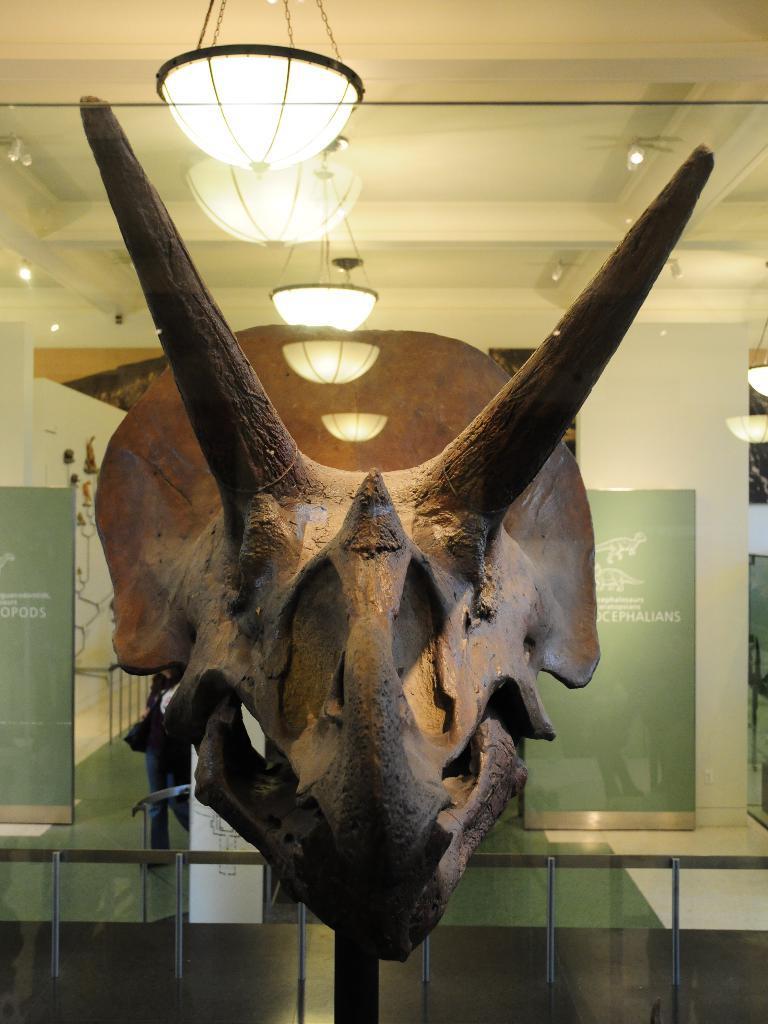Please provide a concise description of this image. In this image in front there is a skull of an animal with the horns. There are photo frames on the glass platform. In the background of the image there is a wall. On top of the image there are lights. At the bottom of the image there is a floor. 